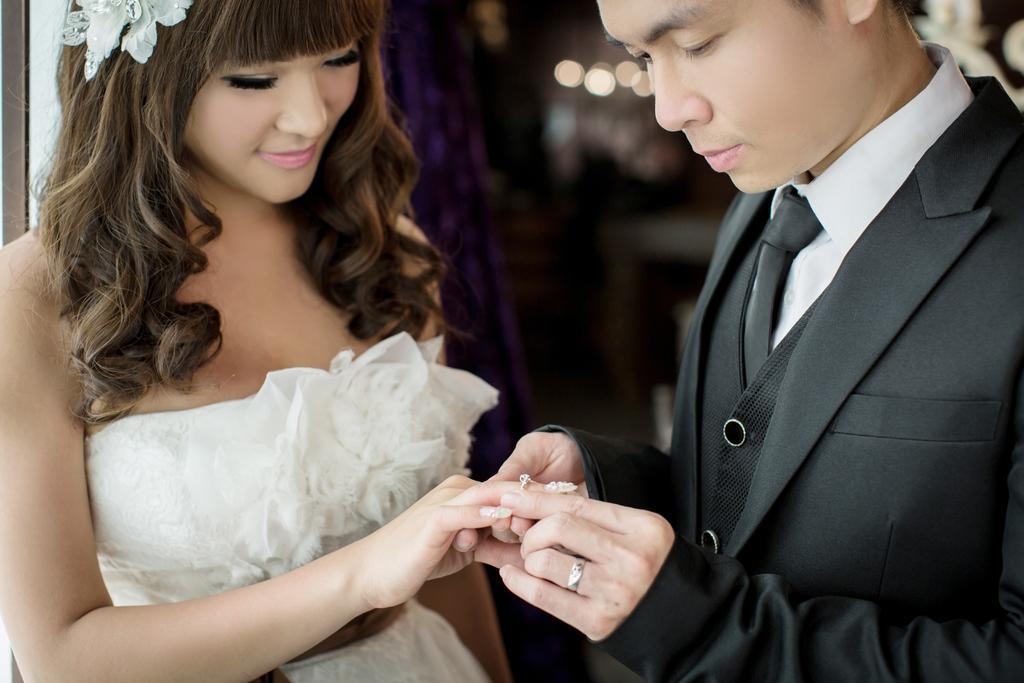Describe this image in one or two sentences. To the left side of the image there is a lady wearing white color dress. To the right side of the image there is a person wearing black color suit. he is holding hand of a lady and ring. The background of the image is not clear. 